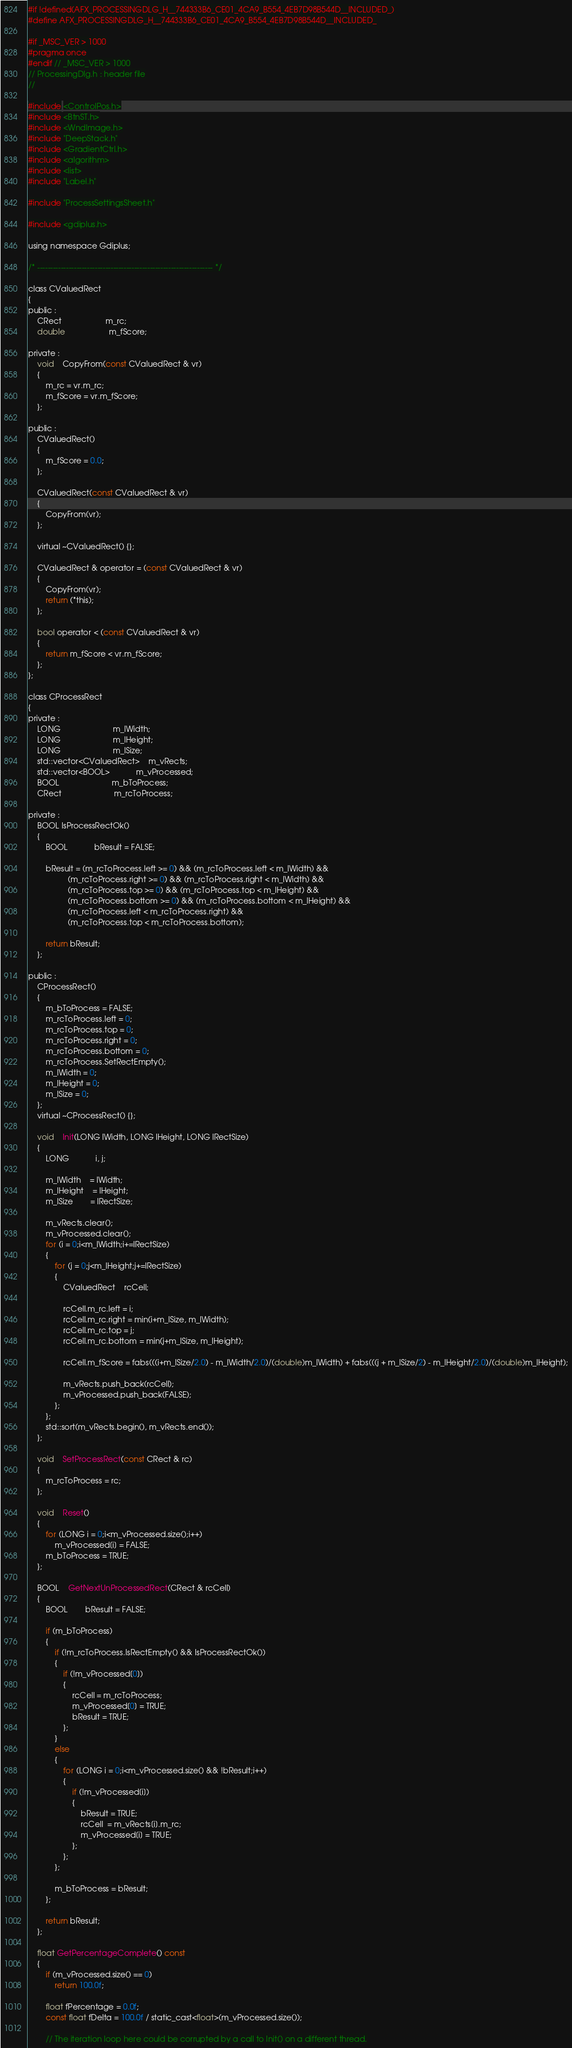<code> <loc_0><loc_0><loc_500><loc_500><_C_>#if !defined(AFX_PROCESSINGDLG_H__744333B6_CE01_4CA9_B554_4EB7D98B544D__INCLUDED_)
#define AFX_PROCESSINGDLG_H__744333B6_CE01_4CA9_B554_4EB7D98B544D__INCLUDED_

#if _MSC_VER > 1000
#pragma once
#endif // _MSC_VER > 1000
// ProcessingDlg.h : header file
//

#include <ControlPos.h>
#include <BtnST.h>
#include <WndImage.h>
#include "DeepStack.h"
#include <GradientCtrl.h>
#include <algorithm>
#include <list>
#include "Label.h"

#include "ProcessSettingsSheet.h"

#include <gdiplus.h>

using namespace Gdiplus;

/* ------------------------------------------------------------------- */

class CValuedRect
{
public :
	CRect					m_rc;
	double					m_fScore;

private :
	void	CopyFrom(const CValuedRect & vr)
	{
		m_rc = vr.m_rc;
		m_fScore = vr.m_fScore;
	};

public :
	CValuedRect()
	{
		m_fScore = 0.0;
	};

	CValuedRect(const CValuedRect & vr)
	{
		CopyFrom(vr);
	};

	virtual ~CValuedRect() {};

	CValuedRect & operator = (const CValuedRect & vr)
	{
		CopyFrom(vr);
		return (*this);
	};

	bool operator < (const CValuedRect & vr)
	{
		return m_fScore < vr.m_fScore;
	};
};

class CProcessRect
{
private :
	LONG						m_lWidth;
	LONG						m_lHeight;
	LONG						m_lSize;
	std::vector<CValuedRect>	m_vRects;
	std::vector<BOOL>			m_vProcessed;
	BOOL						m_bToProcess;
	CRect						m_rcToProcess;

private :
	BOOL IsProcessRectOk()
	{
		BOOL			bResult = FALSE;

		bResult = (m_rcToProcess.left >= 0) && (m_rcToProcess.left < m_lWidth) &&
				  (m_rcToProcess.right >= 0) && (m_rcToProcess.right < m_lWidth) &&
				  (m_rcToProcess.top >= 0) && (m_rcToProcess.top < m_lHeight) &&
				  (m_rcToProcess.bottom >= 0) && (m_rcToProcess.bottom < m_lHeight) &&
				  (m_rcToProcess.left < m_rcToProcess.right) &&
				  (m_rcToProcess.top < m_rcToProcess.bottom);

		return bResult;
	};

public :
	CProcessRect()
	{
		m_bToProcess = FALSE;
		m_rcToProcess.left = 0;
		m_rcToProcess.top = 0;
		m_rcToProcess.right = 0;
		m_rcToProcess.bottom = 0;
		m_rcToProcess.SetRectEmpty();
        m_lWidth = 0;
        m_lHeight = 0;
        m_lSize = 0;
	};
	virtual ~CProcessRect() {};

	void	Init(LONG lWidth, LONG lHeight, LONG lRectSize)
	{
		LONG			i, j;

		m_lWidth	= lWidth;
		m_lHeight	= lHeight;
		m_lSize		= lRectSize;

		m_vRects.clear();
		m_vProcessed.clear();
		for (i = 0;i<m_lWidth;i+=lRectSize)
		{
			for (j = 0;j<m_lHeight;j+=lRectSize)
			{
				CValuedRect	rcCell;

				rcCell.m_rc.left = i;
				rcCell.m_rc.right = min(i+m_lSize, m_lWidth);
				rcCell.m_rc.top = j;
				rcCell.m_rc.bottom = min(j+m_lSize, m_lHeight);

				rcCell.m_fScore = fabs(((i+m_lSize/2.0) - m_lWidth/2.0)/(double)m_lWidth) + fabs(((j + m_lSize/2) - m_lHeight/2.0)/(double)m_lHeight);

				m_vRects.push_back(rcCell);
				m_vProcessed.push_back(FALSE);
			};
		};
		std::sort(m_vRects.begin(), m_vRects.end());
	};

	void	SetProcessRect(const CRect & rc)
	{
		m_rcToProcess = rc;
	};

	void	Reset()
	{
		for (LONG i = 0;i<m_vProcessed.size();i++)
			m_vProcessed[i] = FALSE;
		m_bToProcess = TRUE;
	};

	BOOL	GetNextUnProcessedRect(CRect & rcCell)
	{
		BOOL		bResult = FALSE;

		if (m_bToProcess)
		{
			if (!m_rcToProcess.IsRectEmpty() && IsProcessRectOk())
			{
				if (!m_vProcessed[0])
				{
					rcCell = m_rcToProcess;
					m_vProcessed[0] = TRUE;
					bResult = TRUE;
				};
			}
			else
			{
				for (LONG i = 0;i<m_vProcessed.size() && !bResult;i++)
				{
					if (!m_vProcessed[i])
					{
						bResult = TRUE;
						rcCell  = m_vRects[i].m_rc;
						m_vProcessed[i] = TRUE;
					};
				};
			};

			m_bToProcess = bResult;
		};

		return bResult;
	};

	float GetPercentageComplete() const
	{
		if (m_vProcessed.size() == 0)
			return 100.0f;

		float fPercentage = 0.0f;
		const float fDelta = 100.0f / static_cast<float>(m_vProcessed.size());

		// The iteration loop here could be corrupted by a call to Init() on a different thread.</code> 